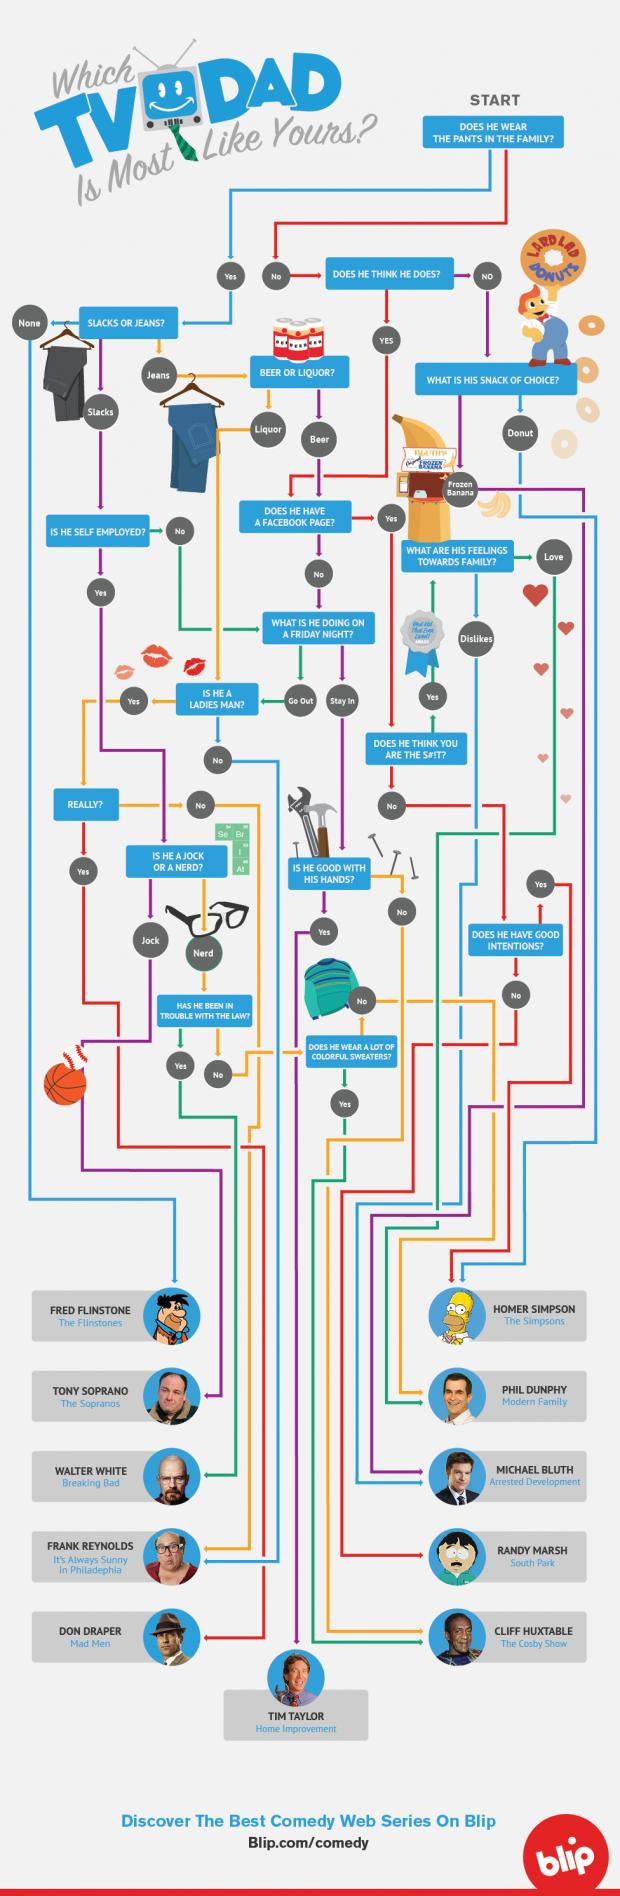List a handful of essential elements in this visual. The sweater icon is depicted as being either green or red. 